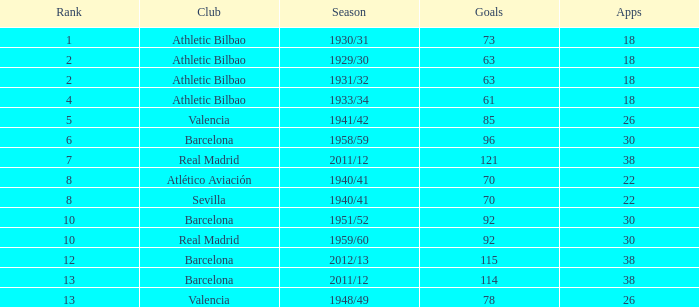Would you mind parsing the complete table? {'header': ['Rank', 'Club', 'Season', 'Goals', 'Apps'], 'rows': [['1', 'Athletic Bilbao', '1930/31', '73', '18'], ['2', 'Athletic Bilbao', '1929/30', '63', '18'], ['2', 'Athletic Bilbao', '1931/32', '63', '18'], ['4', 'Athletic Bilbao', '1933/34', '61', '18'], ['5', 'Valencia', '1941/42', '85', '26'], ['6', 'Barcelona', '1958/59', '96', '30'], ['7', 'Real Madrid', '2011/12', '121', '38'], ['8', 'Atlético Aviación', '1940/41', '70', '22'], ['8', 'Sevilla', '1940/41', '70', '22'], ['10', 'Barcelona', '1951/52', '92', '30'], ['10', 'Real Madrid', '1959/60', '92', '30'], ['12', 'Barcelona', '2012/13', '115', '38'], ['13', 'Barcelona', '2011/12', '114', '38'], ['13', 'Valencia', '1948/49', '78', '26']]} How many apps when the ranking was post 13 and with more than 73 targets? None. 